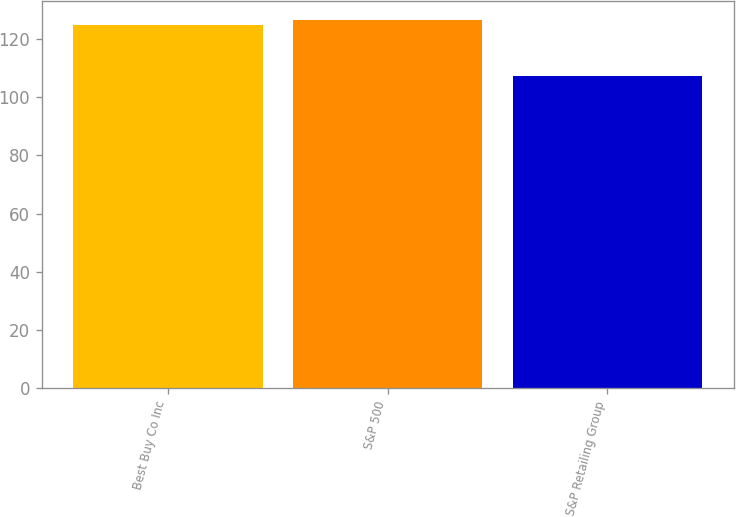<chart> <loc_0><loc_0><loc_500><loc_500><bar_chart><fcel>Best Buy Co Inc<fcel>S&P 500<fcel>S&P Retailing Group<nl><fcel>125.03<fcel>126.81<fcel>107.35<nl></chart> 